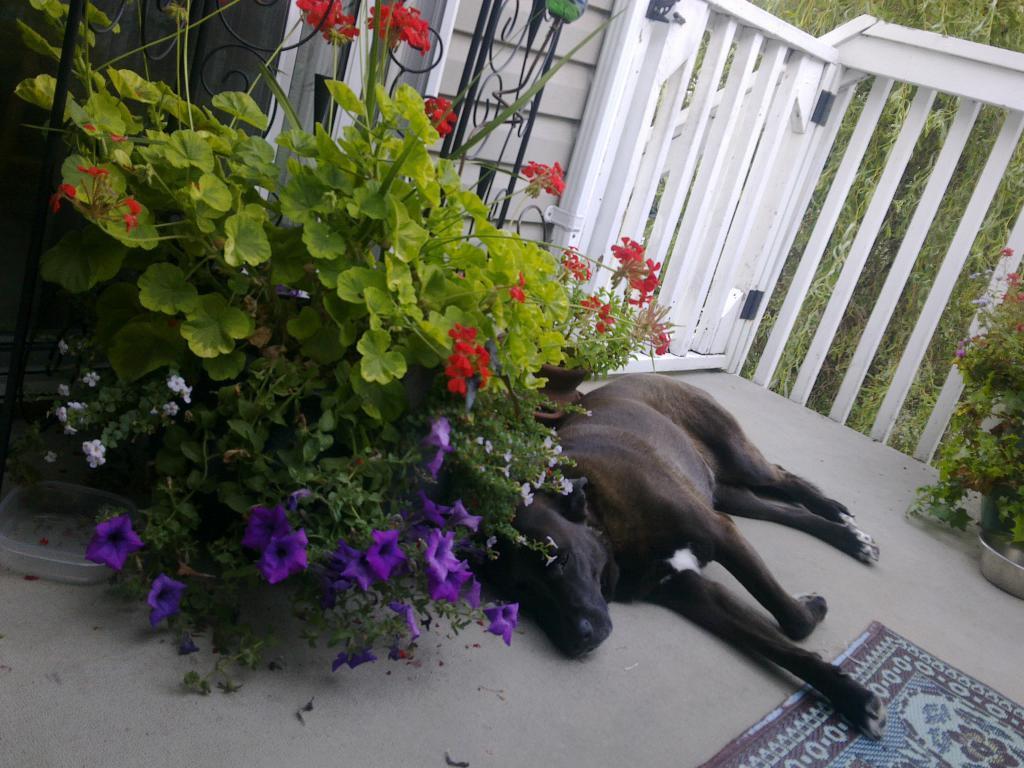Can you describe this image briefly? In this image we can see a dog in black color is laying on the floor. On the left side of the image we can see group of flowers on different plants. In the background, we can see wooden fence and some trees and a carpet on the floor. 